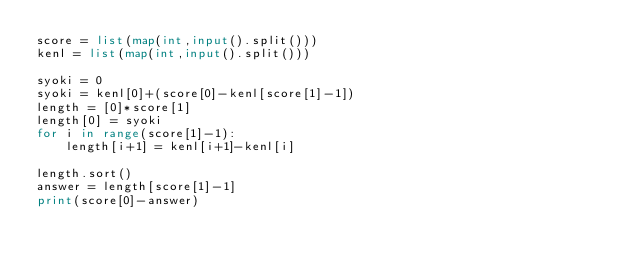Convert code to text. <code><loc_0><loc_0><loc_500><loc_500><_Python_>score = list(map(int,input().split()))
kenl = list(map(int,input().split()))

syoki = 0
syoki = kenl[0]+(score[0]-kenl[score[1]-1])
length = [0]*score[1]
length[0] = syoki
for i in range(score[1]-1):
    length[i+1] = kenl[i+1]-kenl[i]

length.sort()
answer = length[score[1]-1]
print(score[0]-answer)</code> 